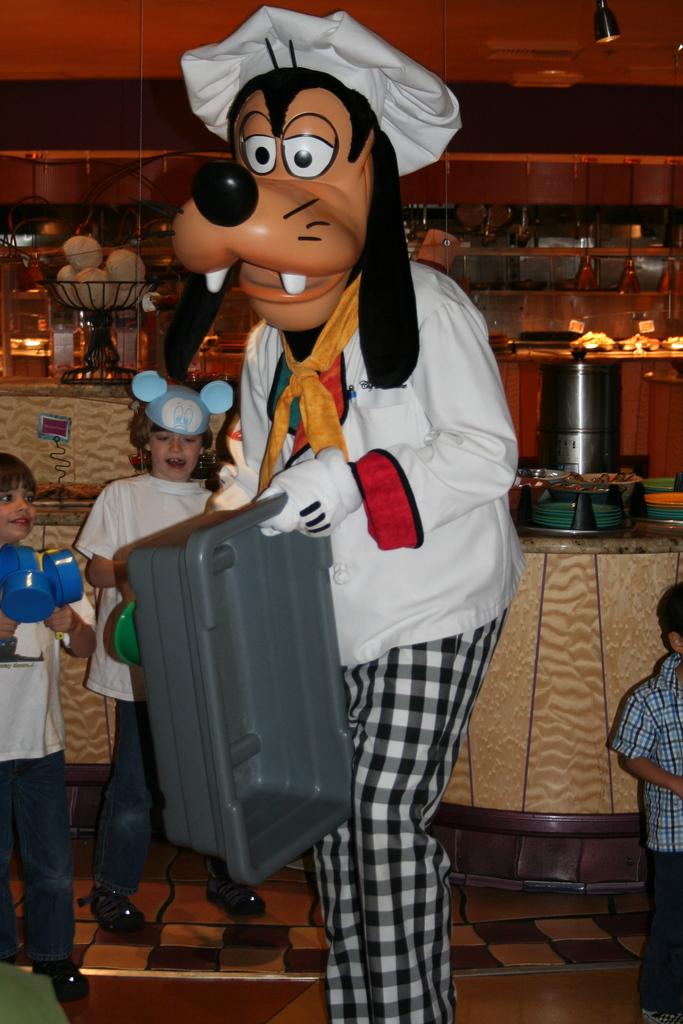What can be seen in the image? There are people in the image. What type of flooring is visible in the image? There are tiles in the image. What object is present in the image that might be used for carrying items? There is a tray in the image. What is a large, flat, and typically vertical surface that can be seen in the image? There is a wall in the image. What type of furniture is present in the image that might be used for holding or displaying items? There are shelves in the image. What type of furniture is present in the image that might be used for placing items on top of? There is a table in the image. What type of polish is being applied to the stage in the image? There is no stage present in the image, and therefore no polish being applied. Can you see any cobwebs on the wall in the image? There is no mention of cobwebs in the image, so we cannot determine their presence. 